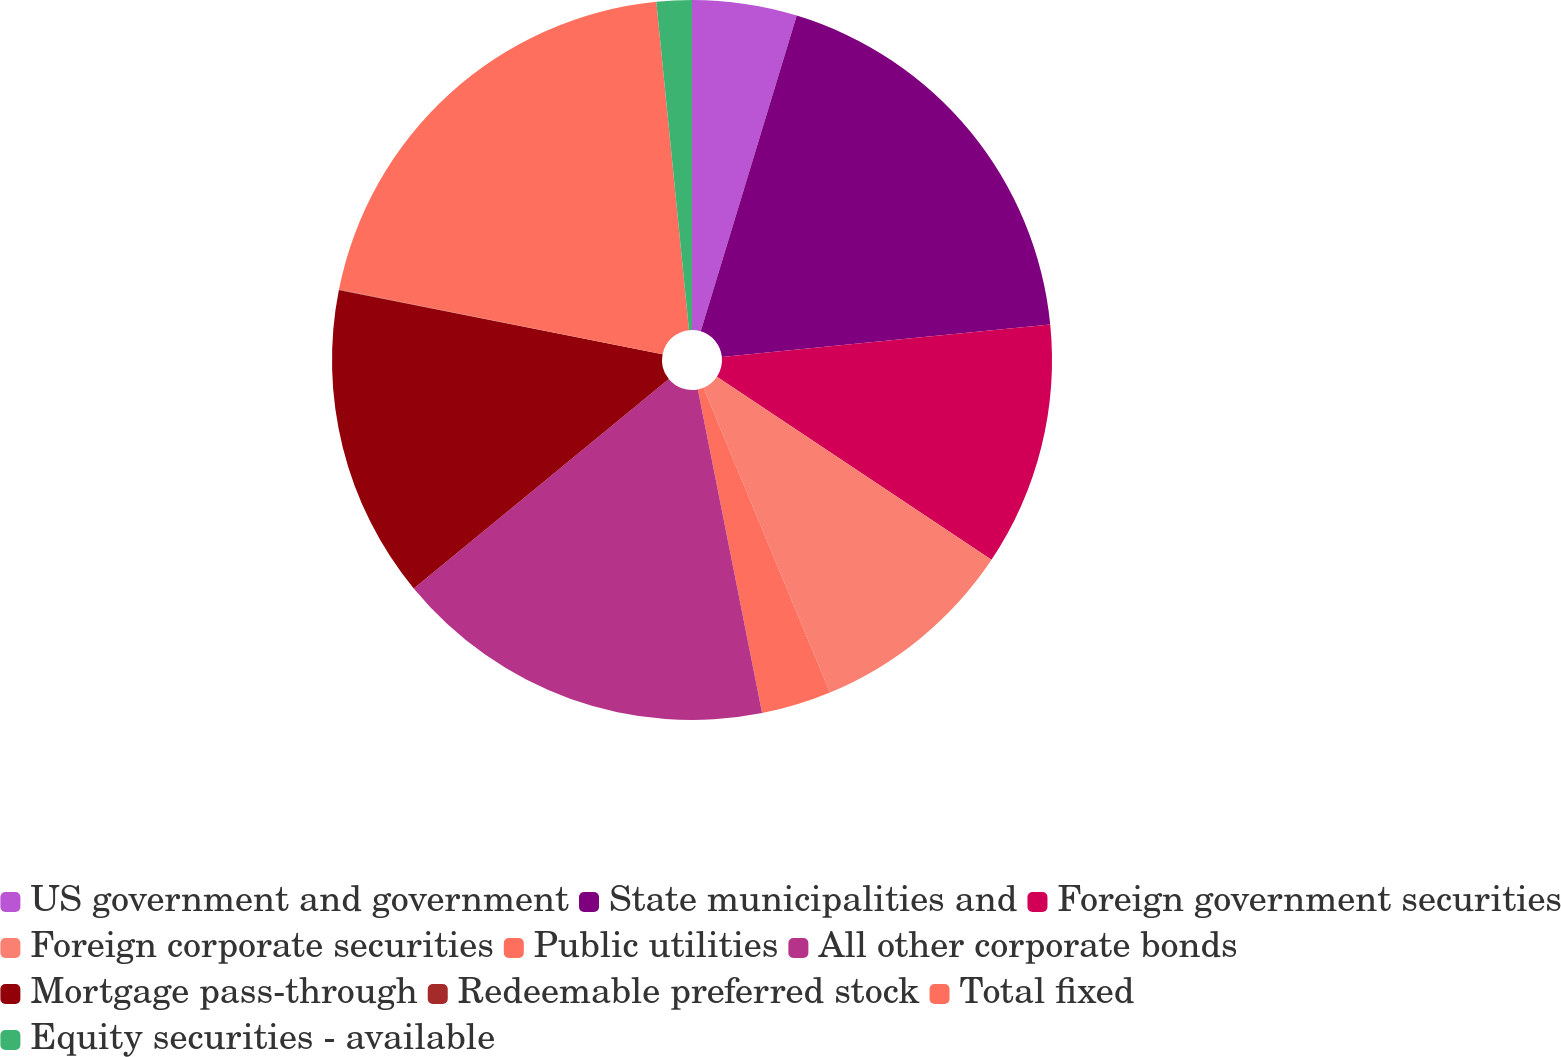<chart> <loc_0><loc_0><loc_500><loc_500><pie_chart><fcel>US government and government<fcel>State municipalities and<fcel>Foreign government securities<fcel>Foreign corporate securities<fcel>Public utilities<fcel>All other corporate bonds<fcel>Mortgage pass-through<fcel>Redeemable preferred stock<fcel>Total fixed<fcel>Equity securities - available<nl><fcel>4.7%<fcel>18.73%<fcel>10.94%<fcel>9.38%<fcel>3.14%<fcel>17.18%<fcel>14.06%<fcel>0.02%<fcel>20.29%<fcel>1.58%<nl></chart> 